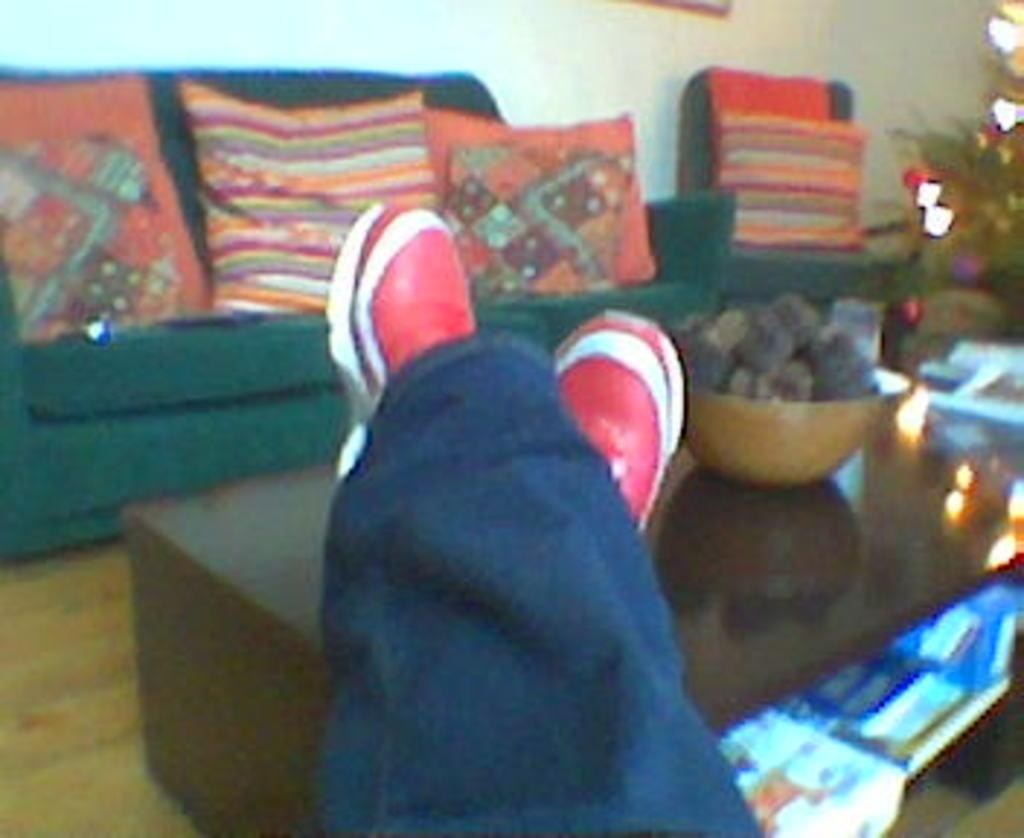What is placed on the table in the image? There are a person's legs on the table. What can be seen in the background of the image? There is a sofa in the background. What is on the sofa in the image? There are pillows on the sofa. What type of cat is sitting on the person's lap in the image? There is no cat present in the image; only a person's legs on the table and a sofa with pillows in the background are visible. 